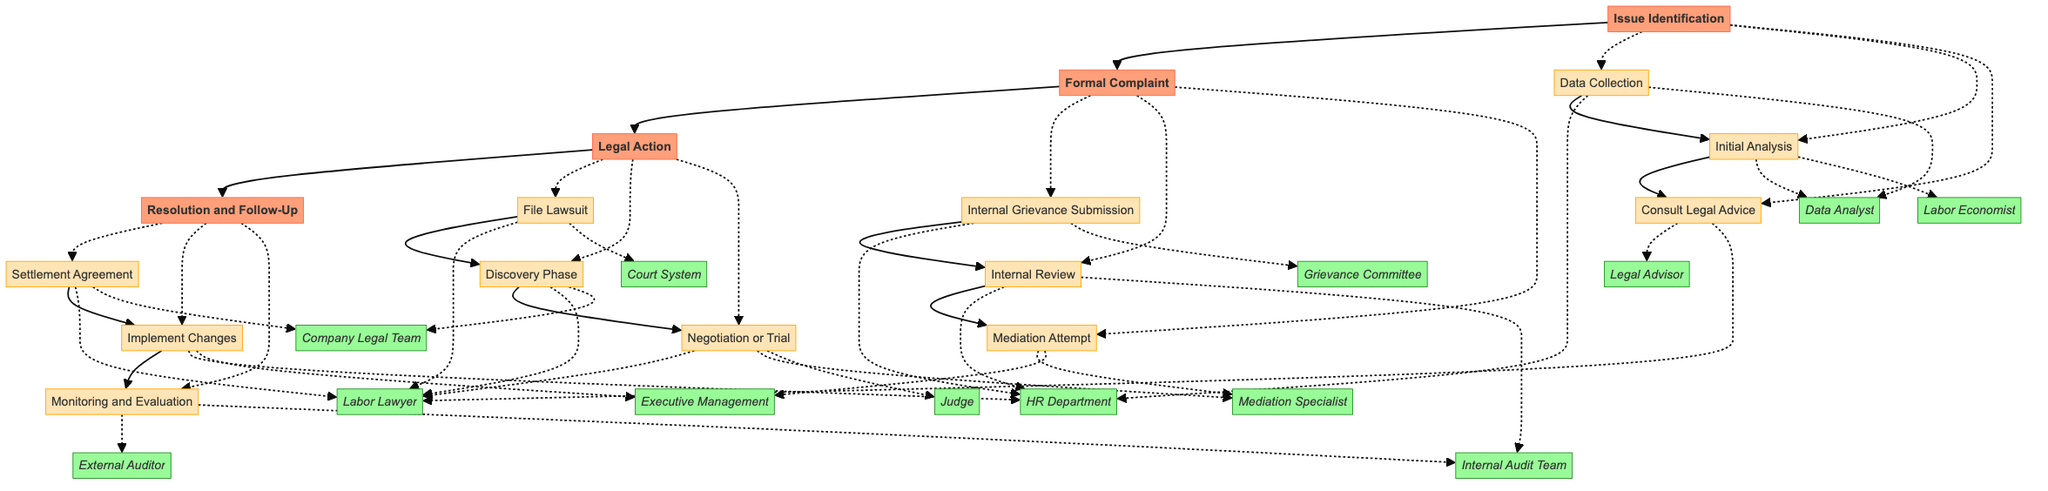What is the first step in the Issue Identification phase? The first step is "Data Collection," which involves gathering salary and promotion data from human resources. This is explicitly listed as the first item under the Issue Identification phase in the diagram.
Answer: Data Collection How many steps are in the Formal Complaint phase? The Formal Complaint phase contains three steps: "Internal Grievance Submission," "Internal Review," and "Mediation Attempt." Counting these steps in the diagram confirms this total.
Answer: 3 Which entity is responsible for conducting the Internal Review? The entity responsible for conducting the Internal Review is the "HR Department," as shown by the connection in the diagram next to that step.
Answer: HR Department What follows the "Discovery Phase" in the Legal Action phase? Following the "Discovery Phase," the next step is "Negotiation or Trial," which is directly connected in the flow of the Legal Action phase in the diagram.
Answer: Negotiation or Trial Who is involved in the Mediation Attempt step? The "Mediation Attempt" step involves the "Mediation Specialist" and "Executive Management," as indicated by the connecting lines to those entities in the diagram.
Answer: Mediation Specialist and Executive Management What is the last step in the Resolution and Follow-Up phase? The last step in the Resolution and Follow-Up phase is "Monitoring and Evaluation," which is clearly marked as the final step in that phase of the diagram.
Answer: Monitoring and Evaluation How are the phases connected in the diagram? The phases are connected in a sequential manner: Issue Identification leads to Formal Complaint, which then leads to Legal Action, followed by Resolution and Follow-Up. This is depicted by arrows between each phase.
Answer: Sequentially connected What is a key action in the Settlement Agreement step? A key action in the Settlement Agreement step is reaching a "settlement agreement or receive a court judgment," which is stated in the description for that step in the diagram.
Answer: Settlement agreement or court judgment 